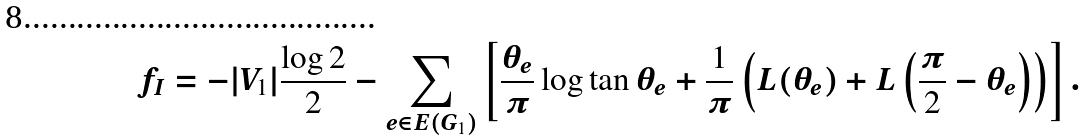<formula> <loc_0><loc_0><loc_500><loc_500>f _ { I } = - | V _ { 1 } | \frac { \log 2 } { 2 } - \sum _ { e \in E ( G _ { 1 } ) } \left [ \frac { \theta _ { e } } { \pi } \log \tan \theta _ { e } + \frac { 1 } { \pi } \left ( L ( \theta _ { e } ) + L \left ( \frac { \pi } { 2 } - \theta _ { e } \right ) \right ) \right ] .</formula> 